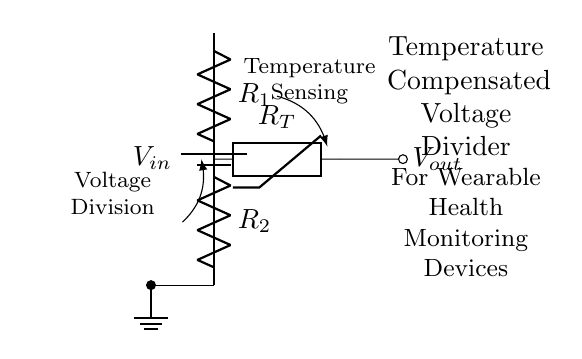What is the purpose of the thermistor in this circuit? The thermistor is used for temperature compensation, allowing the voltage divider's output to remain stable despite temperature variations.
Answer: Temperature compensation What are the two main resistors in the voltage divider? The two main resistors in the voltage divider are labeled R1 and R2, which divide the input voltage to create a stable output voltage.
Answer: R1 and R2 What connects the voltage divider to the power supply? The voltage divider is connected to the power supply via the battery, which provides the input voltage Vin to the circuit.
Answer: Battery What type of device is this voltage divider primarily designed for? This voltage divider is primarily designed for wearable health monitoring devices, as indicated by the labels in the circuit diagram.
Answer: Wearable health monitoring devices How many components are part of this voltage divider circuit? There are three main components in this circuit: two resistors (R1 and R2) and a thermistor (RT) for temperature compensation.
Answer: Three What type of connection is used for the output voltage in this circuit? The output voltage in this circuit is indicated using a short connection that leads to the output node, denoted as Vout.
Answer: Short connection 